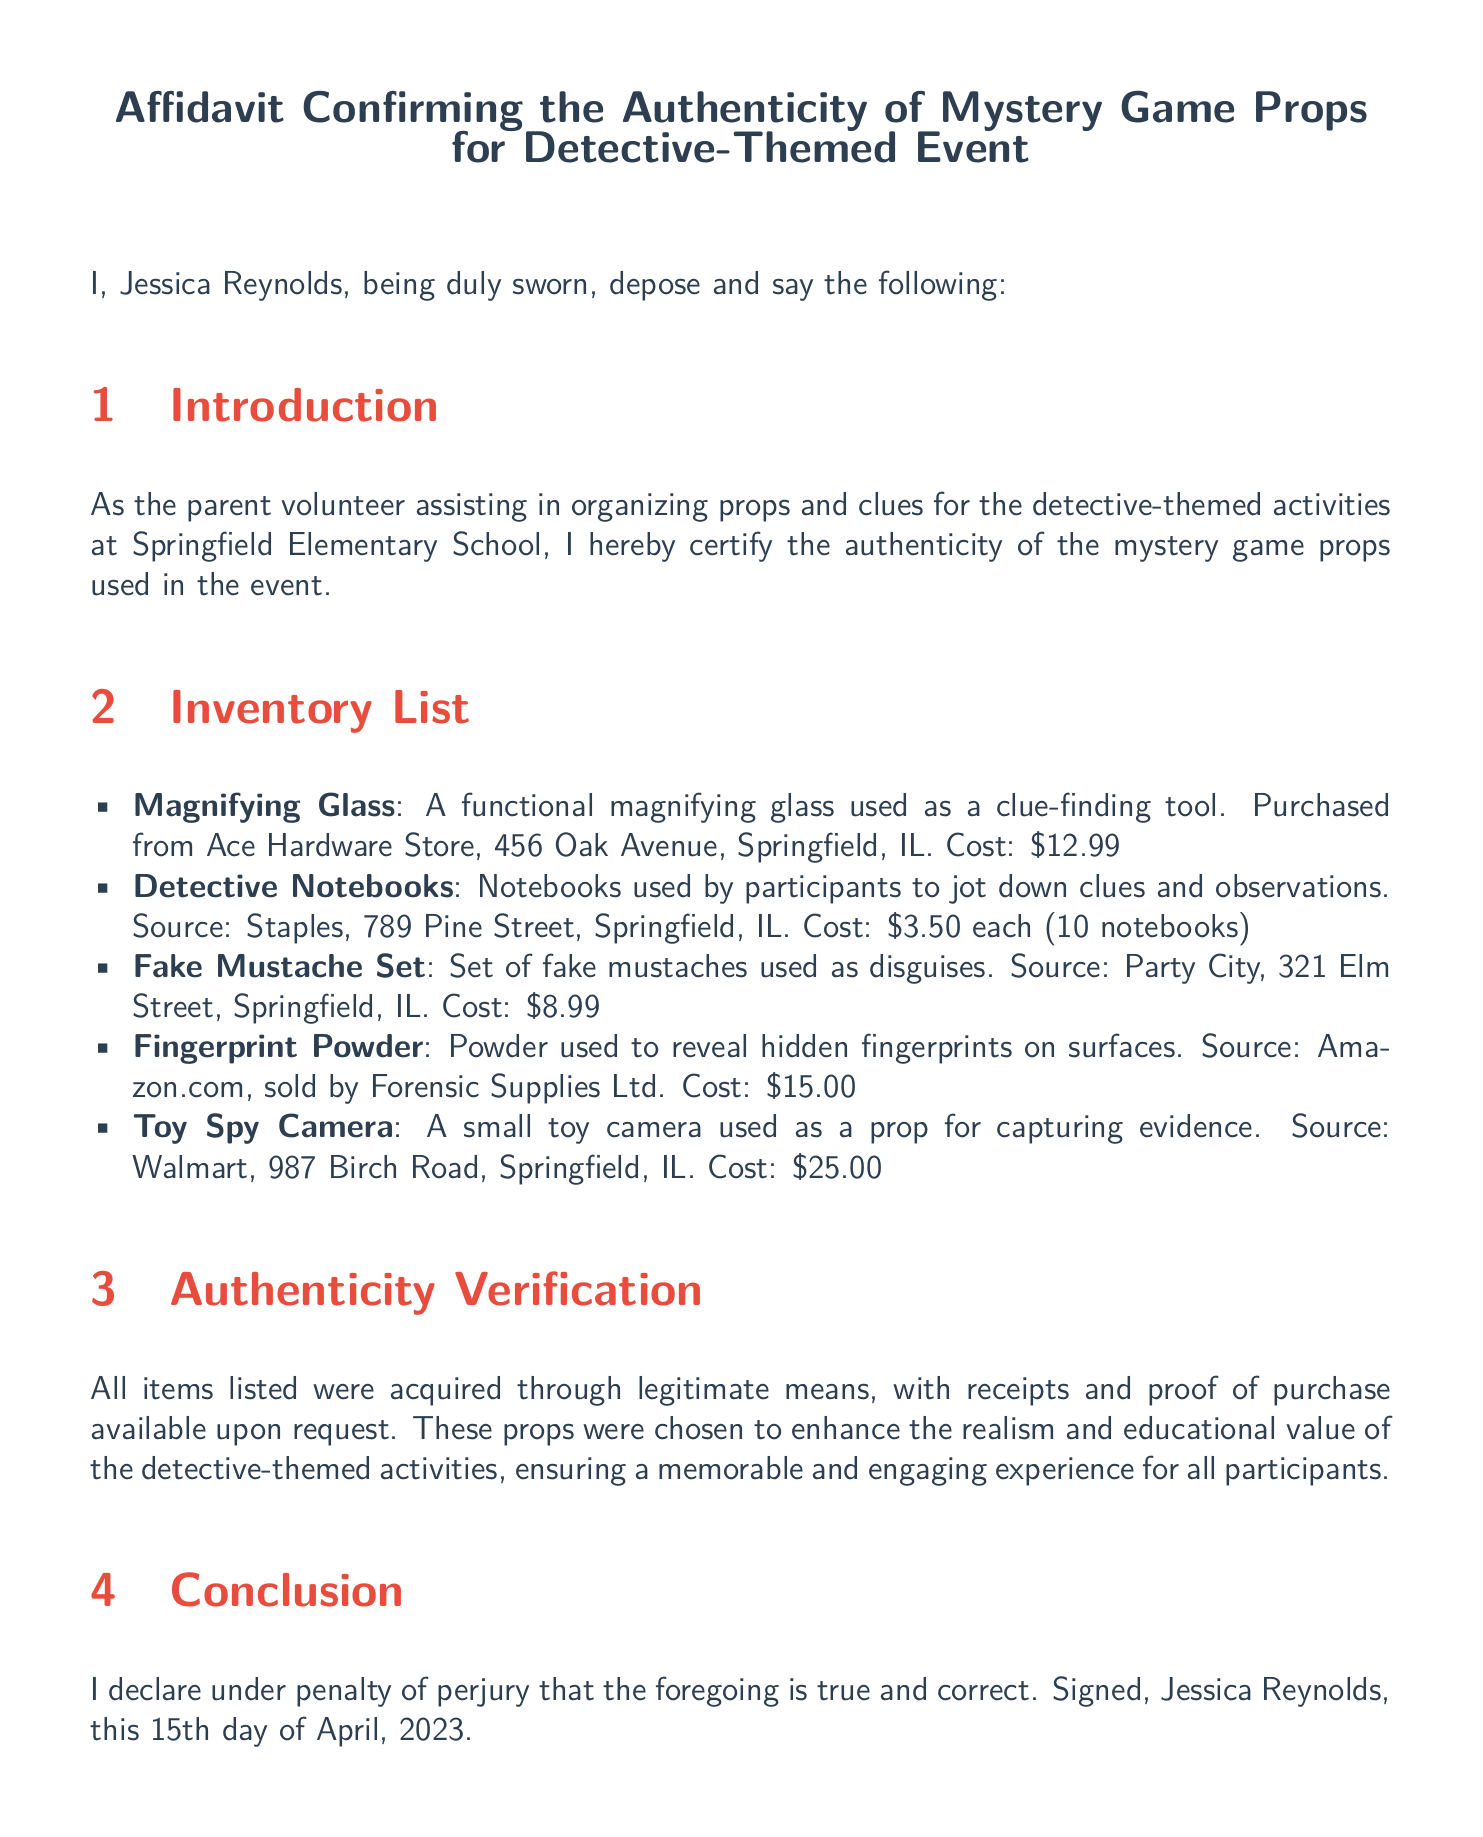What is the name of the affiant? The name of the affiant is mentioned at the beginning of the affidavit.
Answer: Jessica Reynolds What is the total cost of the detective notebooks? The cost per notebook is provided along with the quantity, so the total cost can be calculated.
Answer: $35.00 On what date was the affidavit signed? The signing date is explicitly stated in the conclusion section of the affidavit.
Answer: April 15, 2023 Who is the notary public? The name of the notary public is provided in the document.
Answer: Michael Thompson How many detective notebooks were purchased? The quantity of notebooks is listed in the inventory of props.
Answer: 10 notebooks What is the source of the magnifying glass? The source of the magnifying glass is indicated in the inventory list.
Answer: Ace Hardware Store What item used to enhance realism costs $25.00? The cost of the item is provided along with its description in the inventory.
Answer: Toy Spy Camera What type of affidavit is this document? The particular type of affidavit is specified at the top of the document.
Answer: Affidavit confirming the authenticity of mystery game props Is proof of purchase available upon request? This information is confirmed in the authenticity verification section of the affidavit.
Answer: Yes 